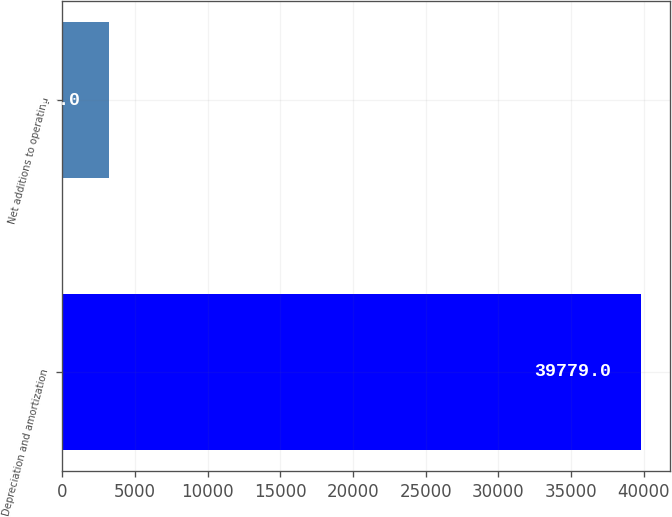Convert chart. <chart><loc_0><loc_0><loc_500><loc_500><bar_chart><fcel>Depreciation and amortization<fcel>Net additions to operating<nl><fcel>39779<fcel>3214<nl></chart> 